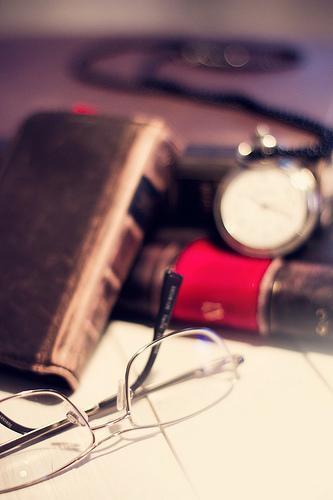How many glasses are there?
Give a very brief answer. 1. 